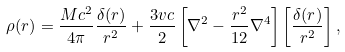Convert formula to latex. <formula><loc_0><loc_0><loc_500><loc_500>\rho ( r ) = \frac { M c ^ { 2 } } { 4 \pi } \frac { \delta ( r ) } { r ^ { 2 } } + \frac { 3 v c } { 2 } \left [ \nabla ^ { 2 } - \frac { r ^ { 2 } } { 1 2 } \nabla ^ { 4 } \right ] \left [ \frac { \delta ( r ) } { r ^ { 2 } } \right ] ,</formula> 